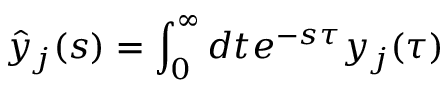<formula> <loc_0><loc_0><loc_500><loc_500>\hat { y } _ { j } ( s ) = \int _ { 0 } ^ { \infty } d t e ^ { - s \tau } y _ { j } ( \tau )</formula> 